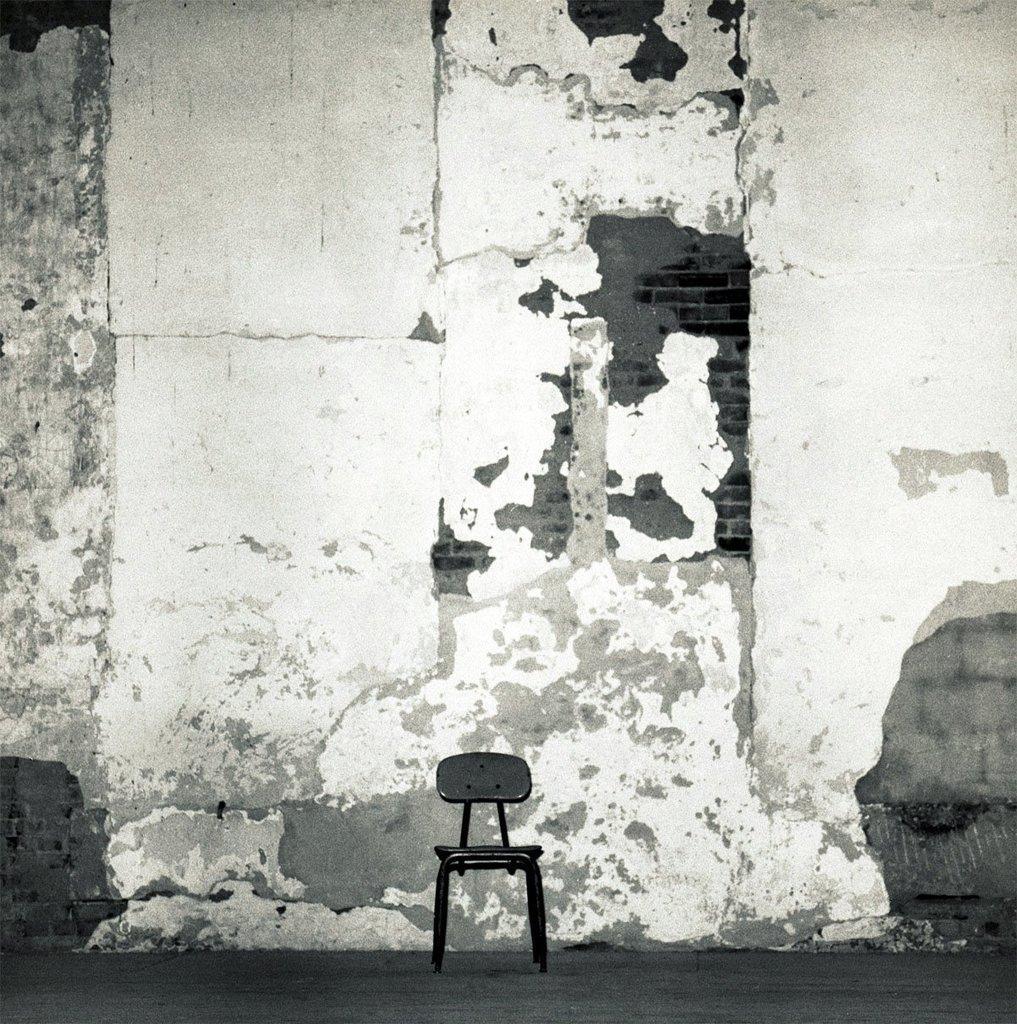Can you describe this image briefly? This is a black and white picture. In the middle of the picture, we see a chair in black color. Behind that, we see a wall in white color. 